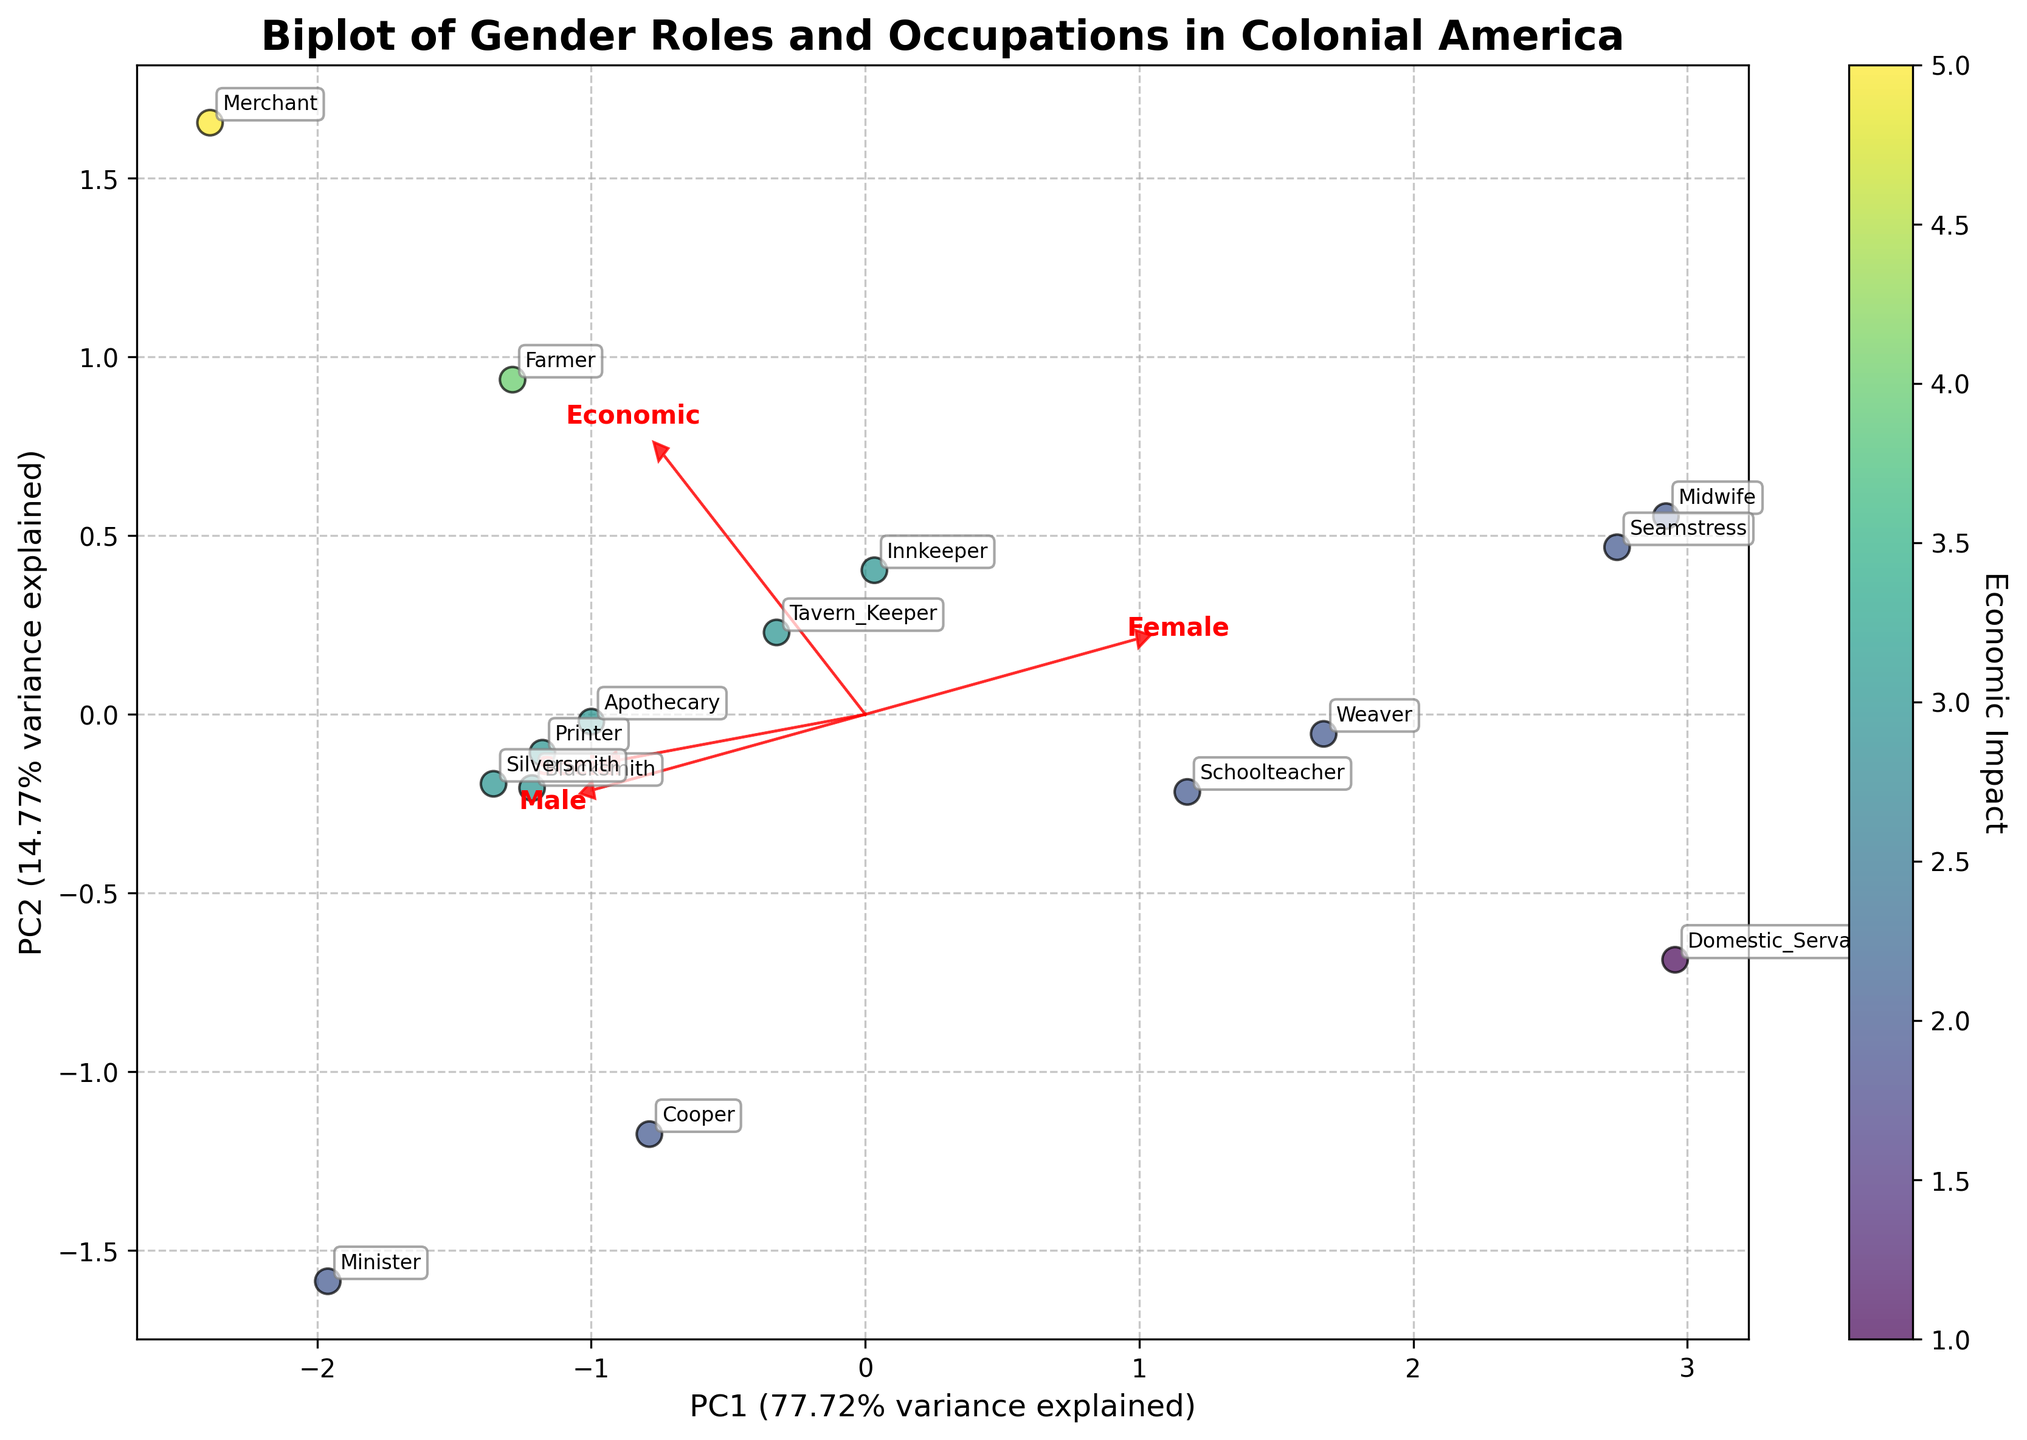What is the title of the biplot? The title of the plot is displayed at the top center of the figure, typically shown in a larger and bold font for visibility. It reads "Biplot of Gender Roles and Occupations in Colonial America".
Answer: Biplot of Gender Roles and Occupations in Colonial America How many principal components are represented in the biplot? The figure explicitly displays two principal components, typically shown along the x-axis and y-axis, and labeled as "PC1" and "PC2".
Answer: 2 Which occupation is represented by a point with the highest Male Participation arrow? The biplot's arrows indicate feature directions, with the Male Participation arrow pointing towards the blacksmith occupation which is located in the same direction as the highest male participation value.
Answer: Blacksmith Which feature has the greatest influence along PC1? The length of the arrows indicates the importance of the features with respect to the principal components. Here, the Male Participation arrow is the longest along PC1.
Answer: Male Participation Which occupation combines a high Female Participation and low Social Status? A point towards the direction of the Female Participation arrow but near the low end of the Social Status scale indicates this combination. The occupation "Domestic Servant" fits this description.
Answer: Domestic Servant What color represents occupations with the highest Economic Impact? A colorbar indicates the correspondence between colors and Economic Impact values. The highest intensity of color (such as the deepest hue in a viridis colormap) corresponds to the highest Economic Impact.
Answer: Deepest color on the colorbar Which occupation has the highest Social Status and what does it indicate? The biplot shows the direction and magnitude of Social Status with its arrow. The occupation of "Minister" is aligned with the highest value, indicating it is deemed the most socially significant in the dataset.
Answer: Minister How are "Schoolteacher" and "Weaver" occupations related in terms of Male Participation and Female Participation? By inspecting the points, both can be seen in similar regions for Male and Female Participation values, suggesting comparable gender participation for these occupations.
Answer: Similar gender participation How do "Merchant" and "Midwife" differ in Economic Impact? Referring to the scatter plot's color gradient, the "Merchant" occupation is shown with a higher Economic Impact (brighter color), while "Midwife" is depicted with a lower Economic Impact (dimmer color).
Answer: Merchant has a higher impact Which component explains more variance, PC1 or PC2? The x and y-axis labels state the explained variance percentage for PC1 and PC2, indicating which component accounts for more data variability. PC1 has the higher variance percentage.
Answer: PC1 